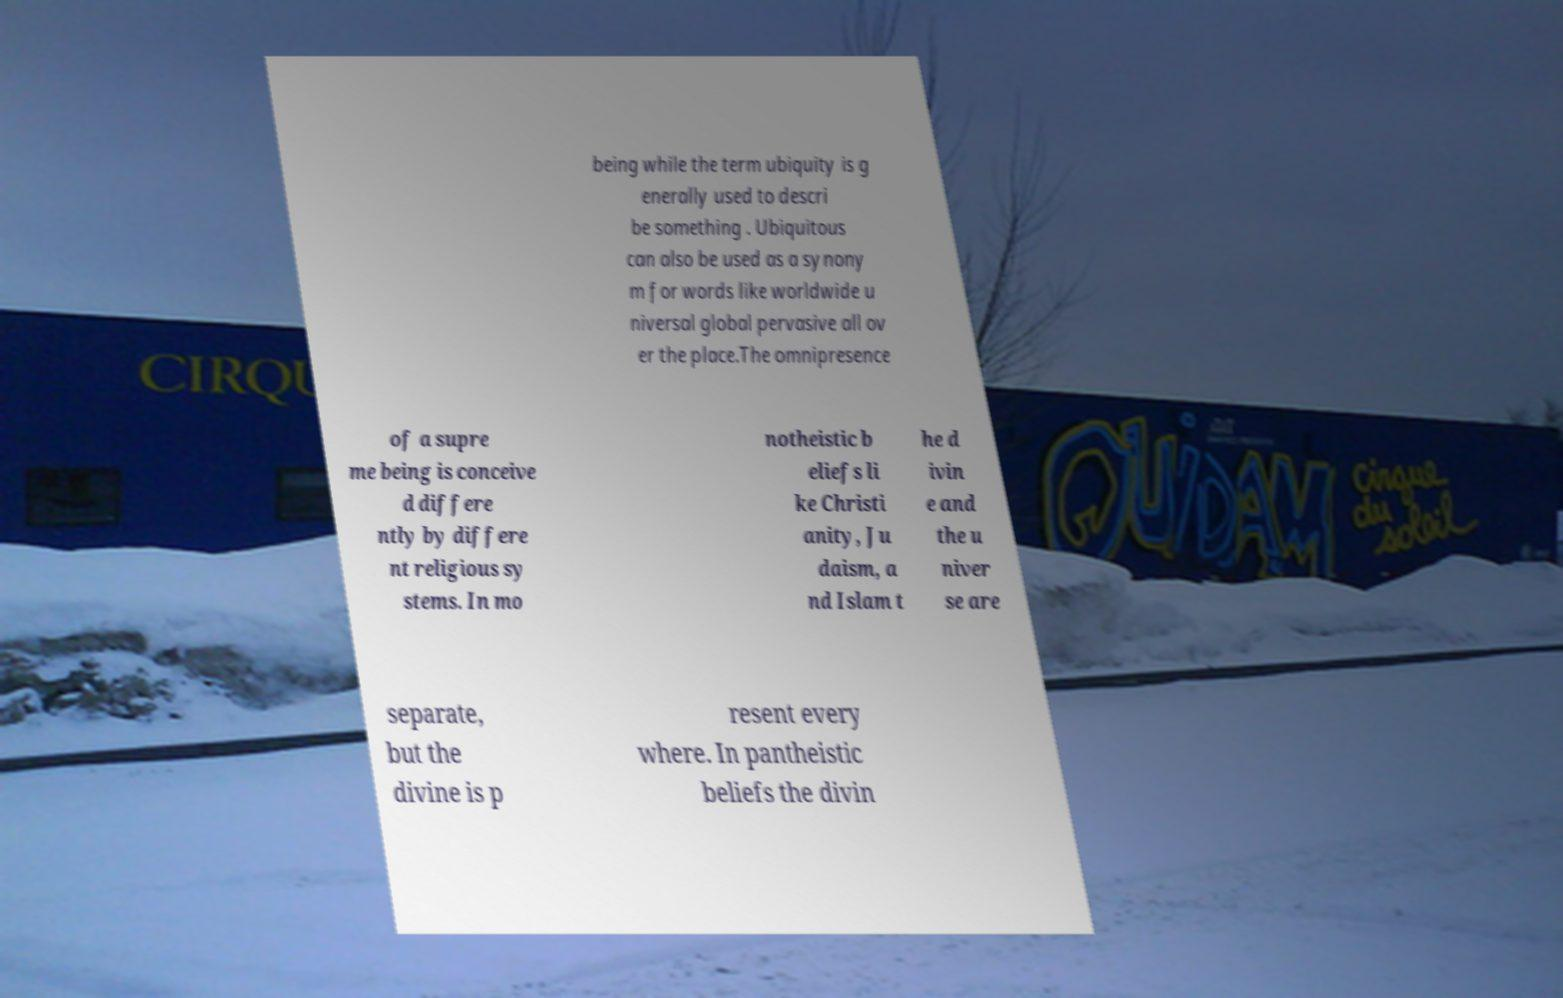Can you accurately transcribe the text from the provided image for me? being while the term ubiquity is g enerally used to descri be something . Ubiquitous can also be used as a synony m for words like worldwide u niversal global pervasive all ov er the place.The omnipresence of a supre me being is conceive d differe ntly by differe nt religious sy stems. In mo notheistic b eliefs li ke Christi anity, Ju daism, a nd Islam t he d ivin e and the u niver se are separate, but the divine is p resent every where. In pantheistic beliefs the divin 